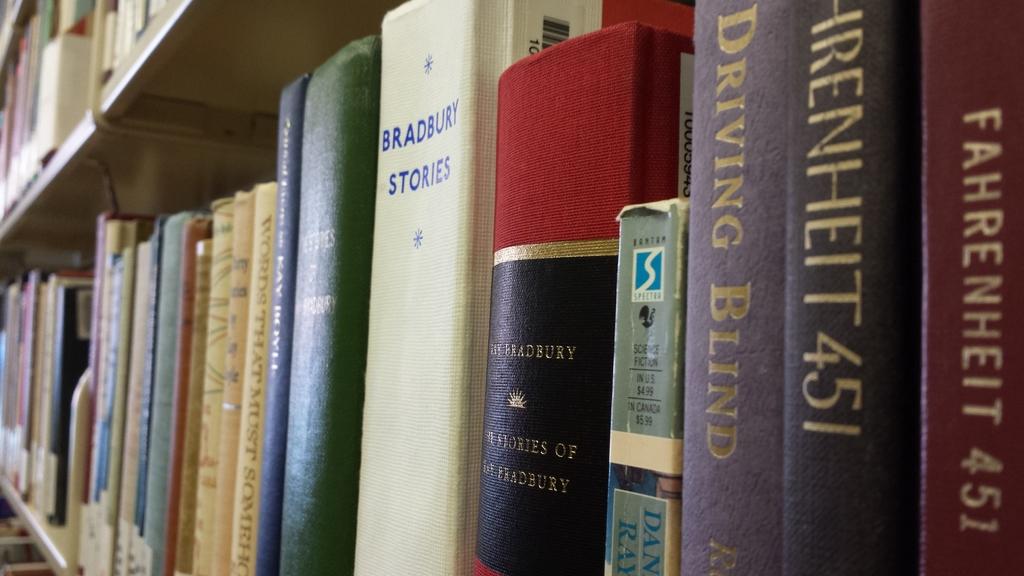What is the name of the right most two books?
Keep it short and to the point. Fahrenheit 451. Whose stories are in the white book?
Give a very brief answer. Bradbury. 